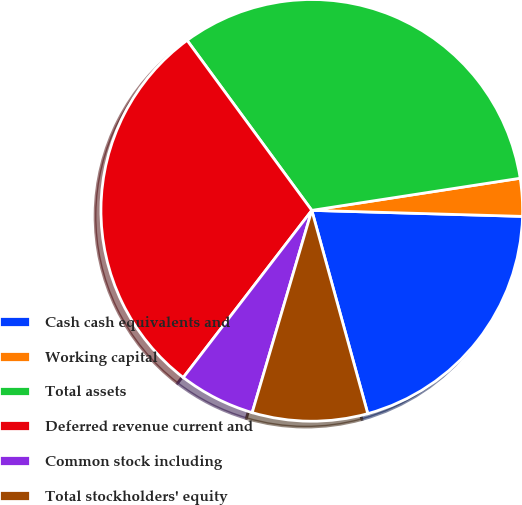<chart> <loc_0><loc_0><loc_500><loc_500><pie_chart><fcel>Cash cash equivalents and<fcel>Working capital<fcel>Total assets<fcel>Deferred revenue current and<fcel>Common stock including<fcel>Total stockholders' equity<nl><fcel>20.27%<fcel>2.89%<fcel>32.64%<fcel>29.5%<fcel>5.87%<fcel>8.84%<nl></chart> 